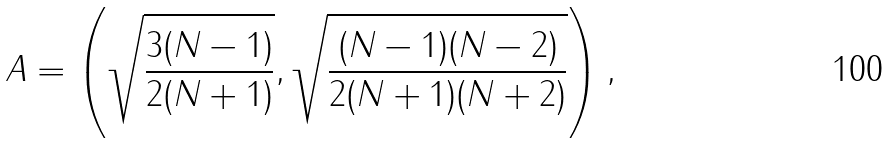<formula> <loc_0><loc_0><loc_500><loc_500>A = \left ( \sqrt { \frac { 3 ( N - 1 ) } { 2 ( N + 1 ) } } , \sqrt { \frac { ( N - 1 ) ( N - 2 ) } { 2 ( N + 1 ) ( N + 2 ) } } \right ) ,</formula> 